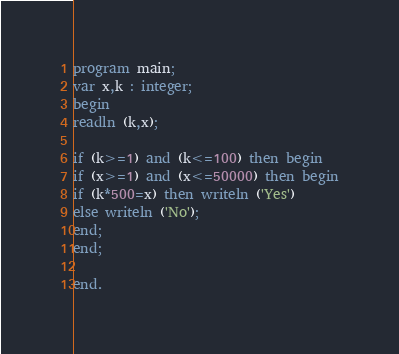Convert code to text. <code><loc_0><loc_0><loc_500><loc_500><_Pascal_>program main;
var x,k : integer;
begin
readln (k,x);

if (k>=1) and (k<=100) then begin
if (x>=1) and (x<=50000) then begin
if (k*500=x) then writeln ('Yes')
else writeln ('No');
end;
end;

end.

</code> 